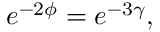<formula> <loc_0><loc_0><loc_500><loc_500>e ^ { - 2 \phi } = e ^ { - 3 \gamma } ,</formula> 